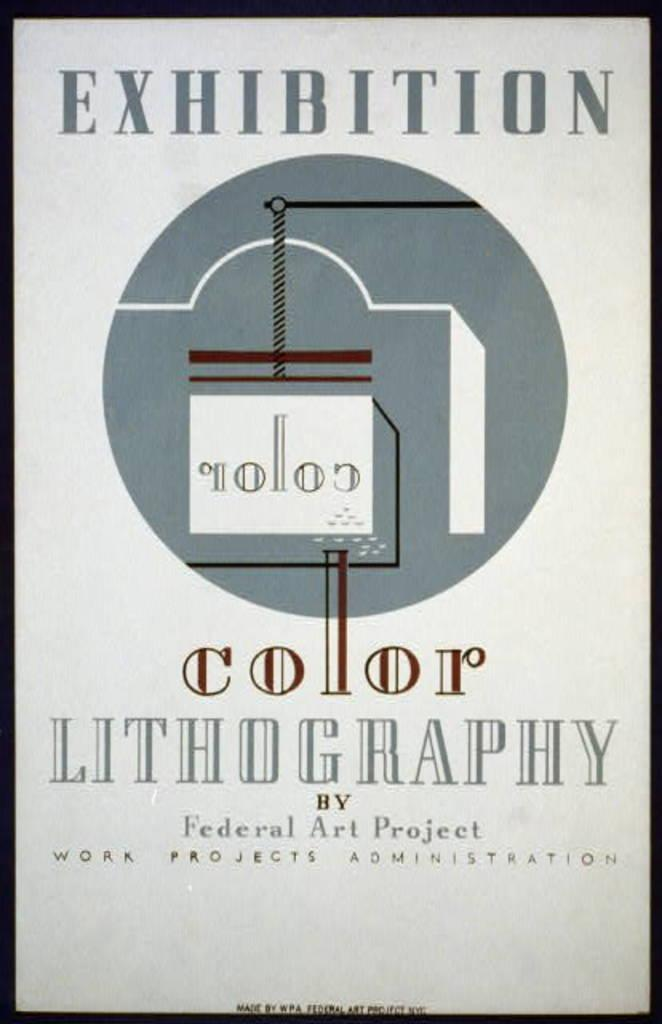Provide a one-sentence caption for the provided image. An older looking copy of a color lithography page by Federal Art Project. 